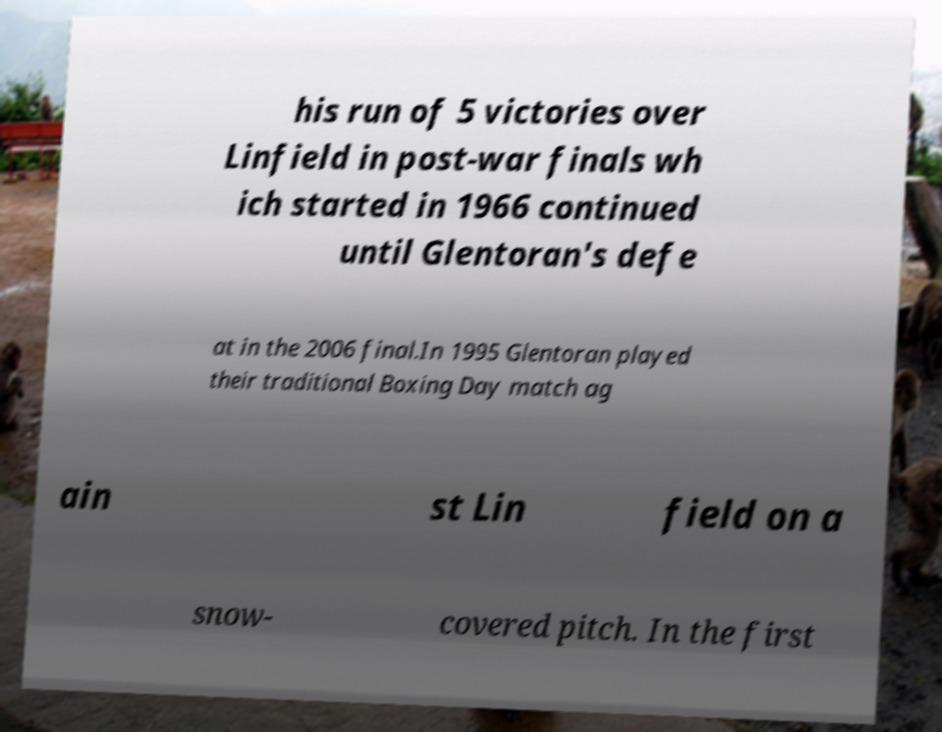I need the written content from this picture converted into text. Can you do that? his run of 5 victories over Linfield in post-war finals wh ich started in 1966 continued until Glentoran's defe at in the 2006 final.In 1995 Glentoran played their traditional Boxing Day match ag ain st Lin field on a snow- covered pitch. In the first 